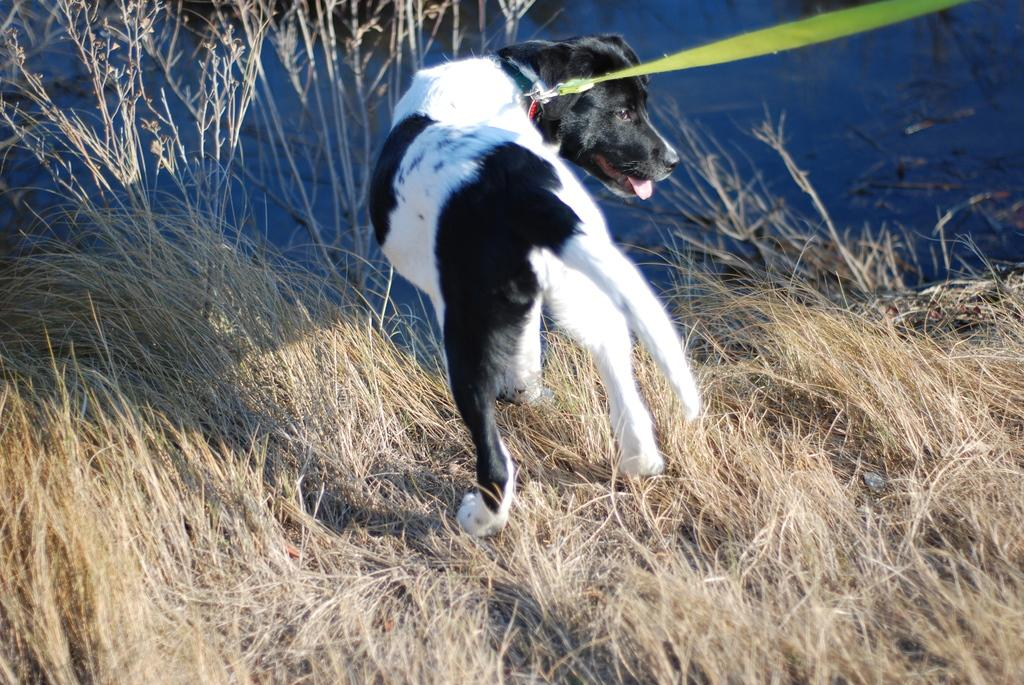What is the main subject in the center of the image? There is a dog in the center of the image. What can be seen at the bottom of the image? There are dry plants at the bottom of the image. What is visible in the background of the image? There is a lake in the background of the image. Can you tell me how many girls are holding the dog in the image? There are no girls present in the image; it only features a dog. What type of tree is growing near the lake in the image? There is no tree visible in the image; it only shows a dog, dry plants, and a lake in the background. 